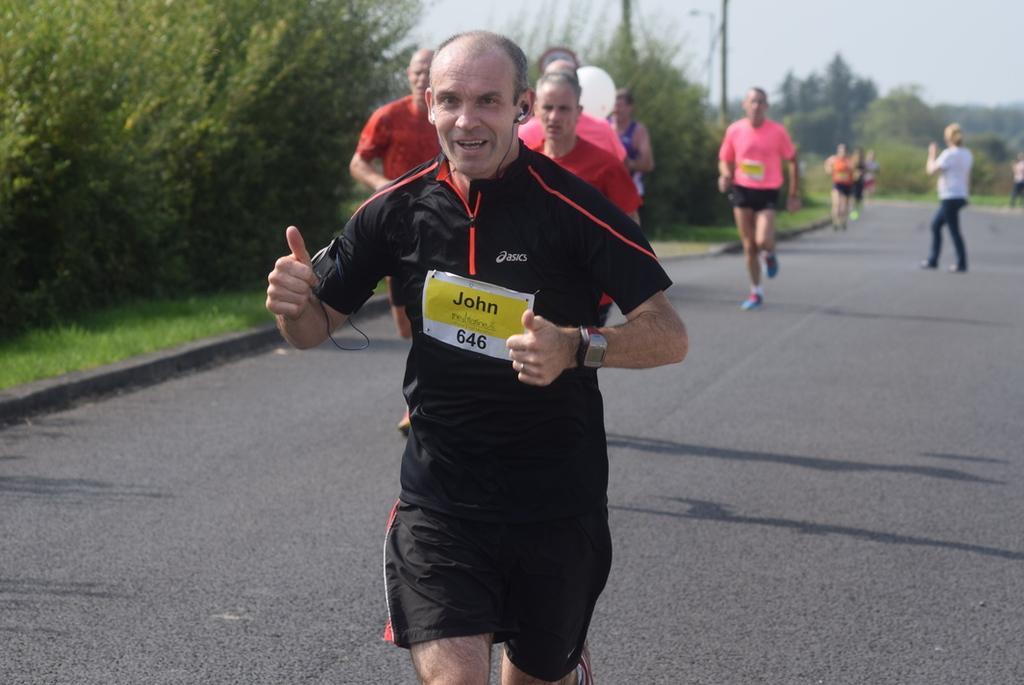Can you describe this image briefly? In this image I can see people among them some are standing and some are running on the road. In the background I can see trees, the grass and the sky. 